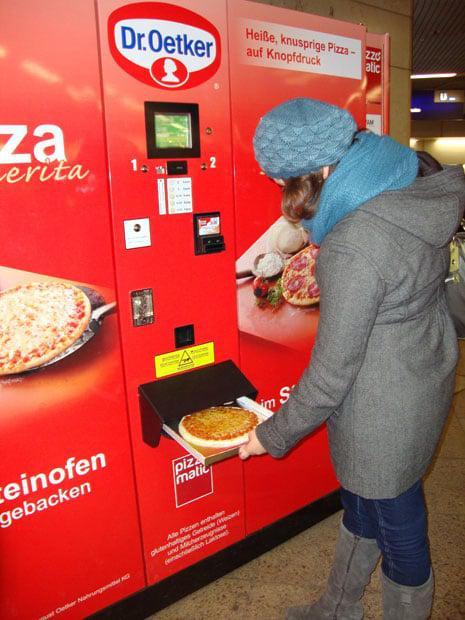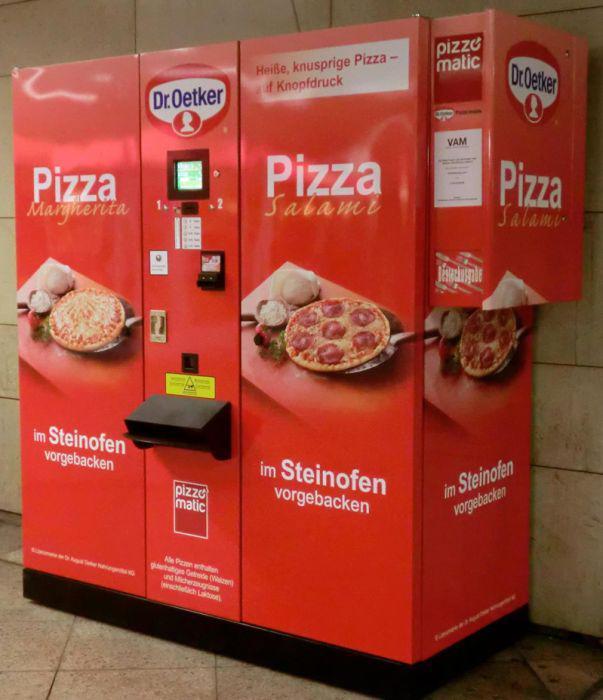The first image is the image on the left, the second image is the image on the right. Examine the images to the left and right. Is the description "Right and left images appear to show the same red pizza vending machine, with the same branding on the front." accurate? Answer yes or no. Yes. 